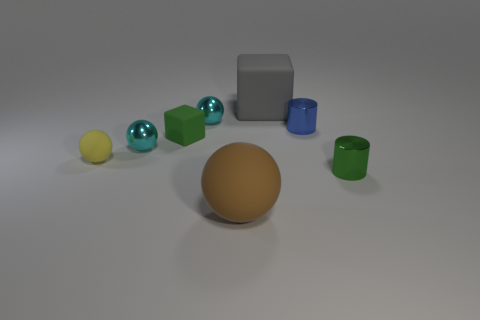There is a blue metal thing in front of the gray rubber thing; how big is it?
Provide a short and direct response. Small. What is the shape of the other green thing that is the same size as the green metallic object?
Offer a terse response. Cube. Do the cylinder behind the tiny green matte block and the tiny green thing that is in front of the tiny matte cube have the same material?
Your answer should be very brief. Yes. What material is the green thing that is in front of the tiny yellow object that is to the left of the gray rubber block made of?
Offer a very short reply. Metal. What size is the cyan metallic thing that is behind the tiny metallic object left of the tiny cyan metallic thing that is to the right of the small green rubber thing?
Keep it short and to the point. Small. Is the yellow rubber ball the same size as the green cylinder?
Offer a very short reply. Yes. There is a green object that is on the left side of the blue metallic thing; does it have the same shape as the big rubber thing that is in front of the green shiny thing?
Give a very brief answer. No. Is there a large gray cube behind the tiny green object on the left side of the large gray thing?
Offer a terse response. Yes. Are any tiny blue shiny objects visible?
Ensure brevity in your answer.  Yes. What number of metallic spheres are the same size as the blue metallic cylinder?
Keep it short and to the point. 2. 